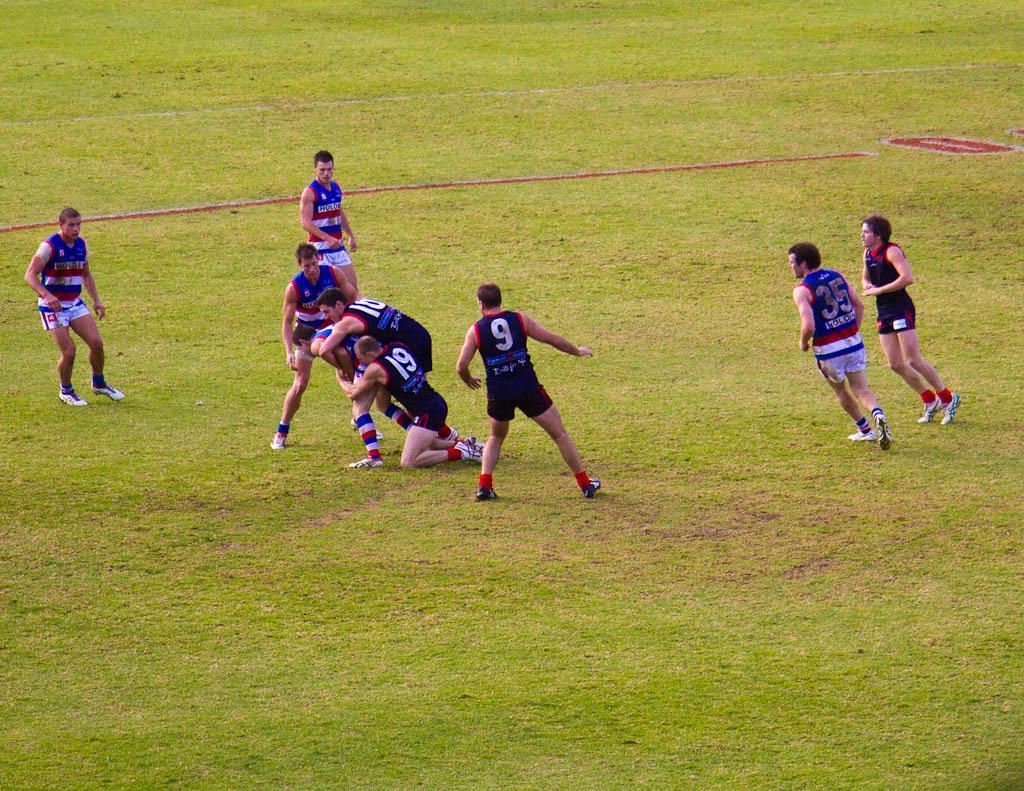Can you describe this image briefly? In this image in the center there are persons playing and there's grass on the ground. 